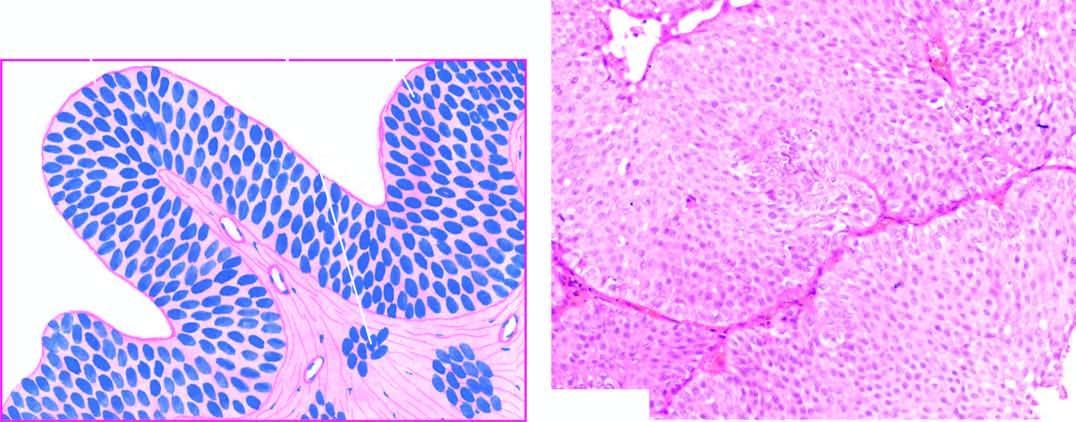what are still recognisable as of transitional origin and show features of anaplasia?
Answer the question using a single word or phrase. Cells 